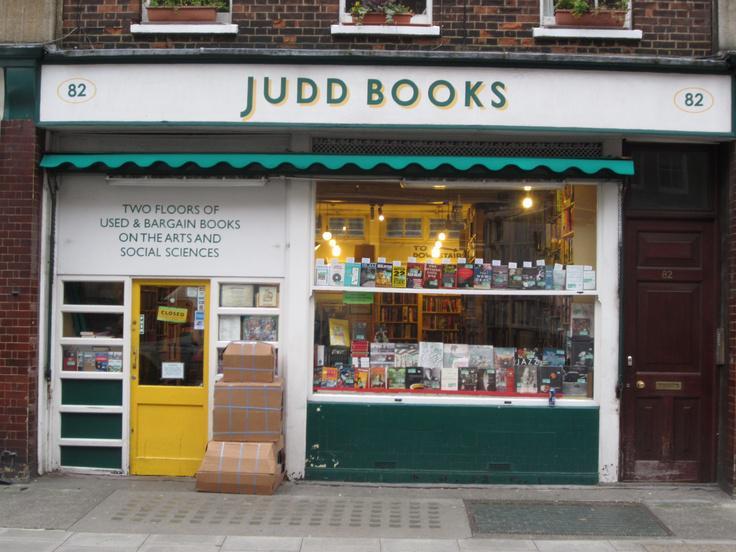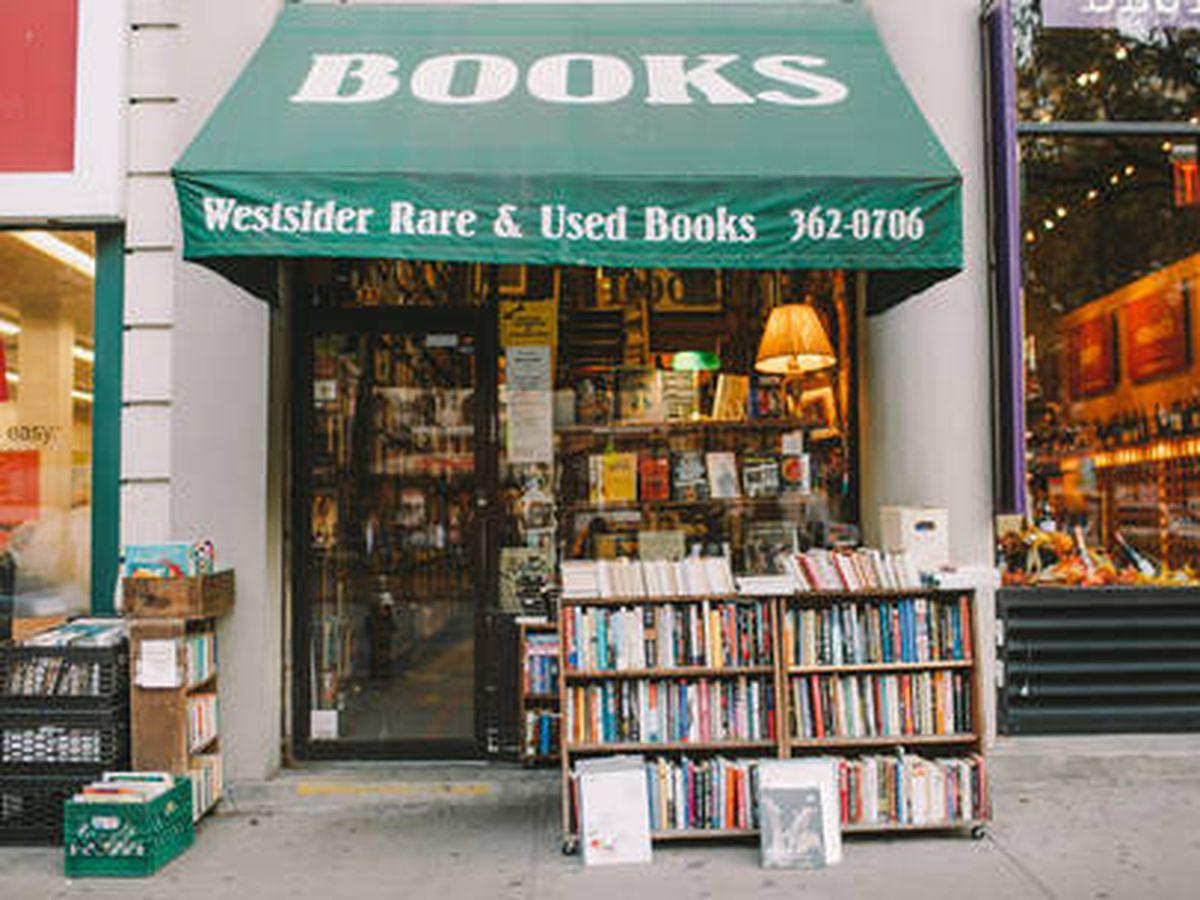The first image is the image on the left, the second image is the image on the right. Given the left and right images, does the statement "Outside store front view of used bookstores." hold true? Answer yes or no. Yes. 